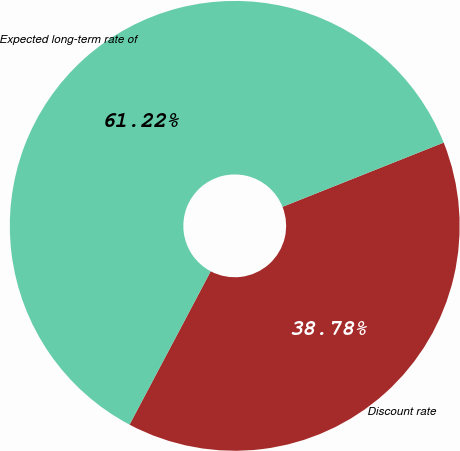Convert chart to OTSL. <chart><loc_0><loc_0><loc_500><loc_500><pie_chart><fcel>Discount rate<fcel>Expected long-term rate of<nl><fcel>38.78%<fcel>61.22%<nl></chart> 